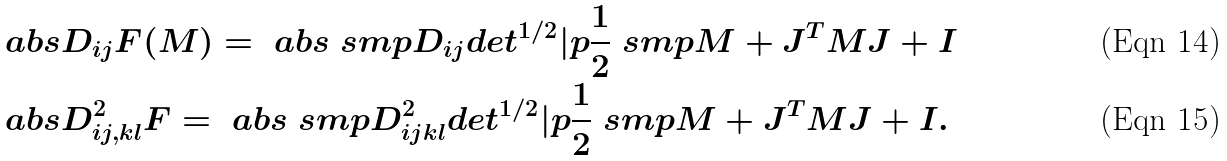Convert formula to latex. <formula><loc_0><loc_0><loc_500><loc_500>& \ a b s { D _ { i j } F ( M ) } = \ a b s { \ s m p { D _ { i j } d e t ^ { 1 / 2 } } | p { \frac { 1 } { 2 } \ s m p { M + J ^ { T } M J } + I } } \\ & \ a b s { D _ { i j , k l } ^ { 2 } F } = \ a b s { \ s m p { D _ { i j k l } ^ { 2 } d e t ^ { 1 / 2 } } | p { \frac { 1 } { 2 } \ s m p { M + J ^ { T } M J } + I } } .</formula> 